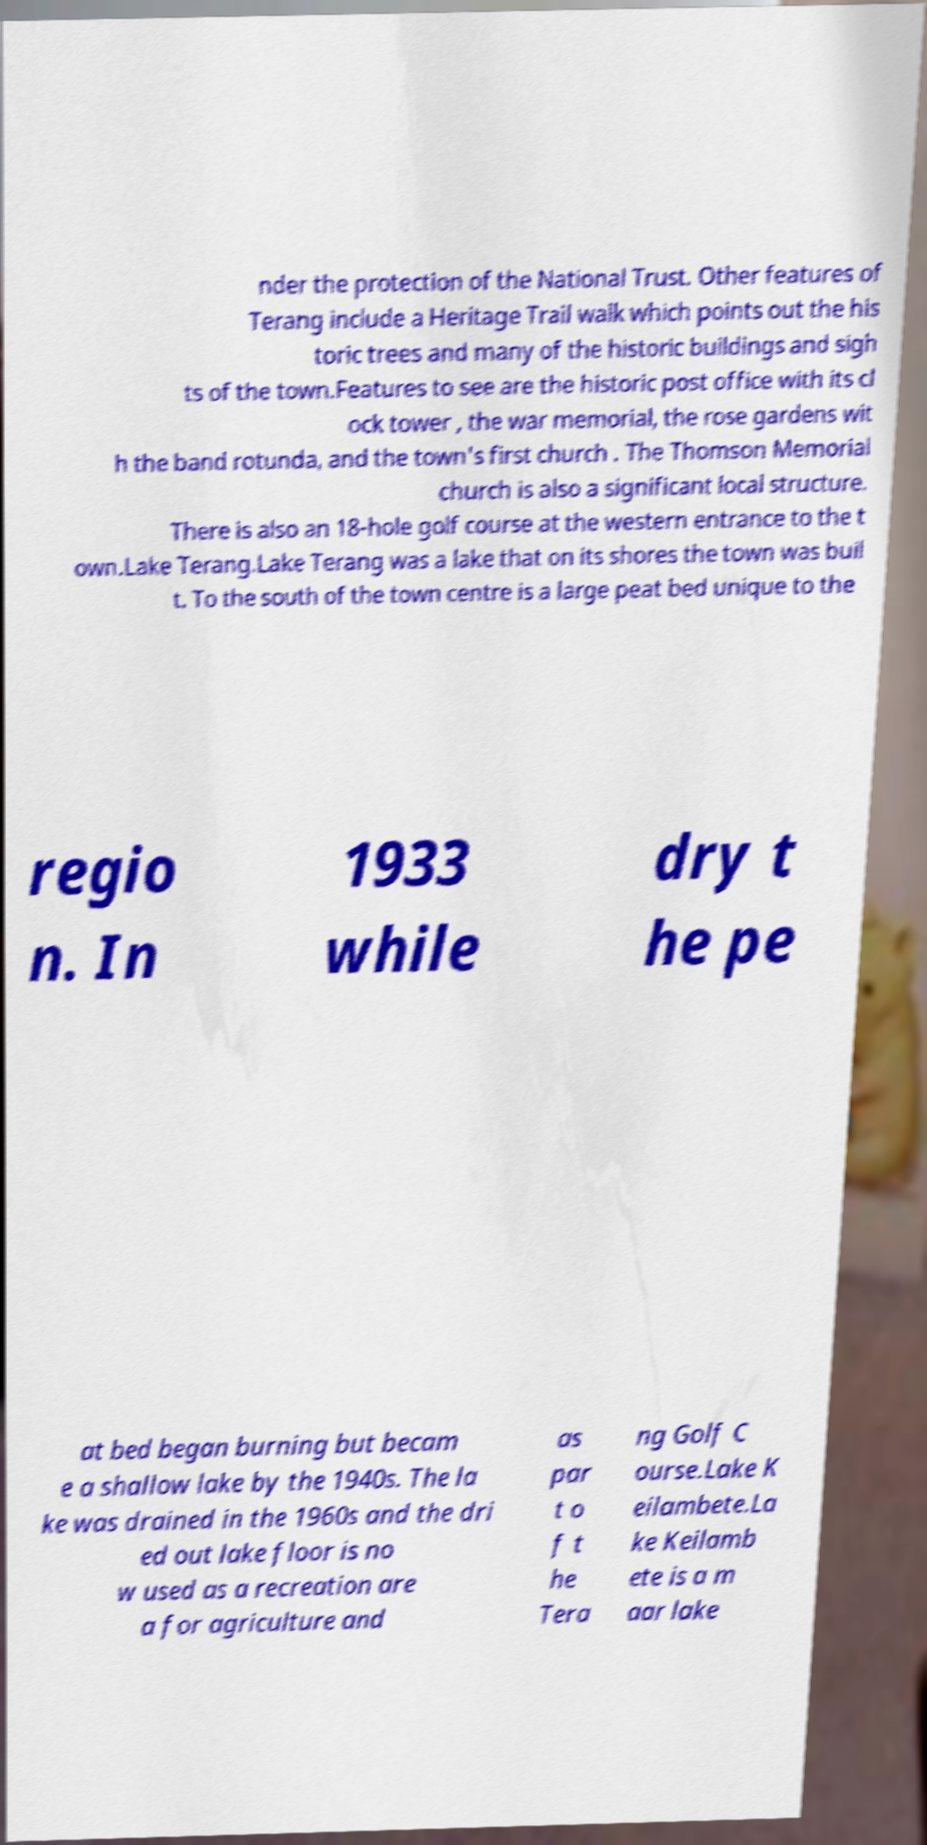Can you read and provide the text displayed in the image?This photo seems to have some interesting text. Can you extract and type it out for me? nder the protection of the National Trust. Other features of Terang include a Heritage Trail walk which points out the his toric trees and many of the historic buildings and sigh ts of the town.Features to see are the historic post office with its cl ock tower , the war memorial, the rose gardens wit h the band rotunda, and the town's first church . The Thomson Memorial church is also a significant local structure. There is also an 18-hole golf course at the western entrance to the t own.Lake Terang.Lake Terang was a lake that on its shores the town was buil t. To the south of the town centre is a large peat bed unique to the regio n. In 1933 while dry t he pe at bed began burning but becam e a shallow lake by the 1940s. The la ke was drained in the 1960s and the dri ed out lake floor is no w used as a recreation are a for agriculture and as par t o f t he Tera ng Golf C ourse.Lake K eilambete.La ke Keilamb ete is a m aar lake 